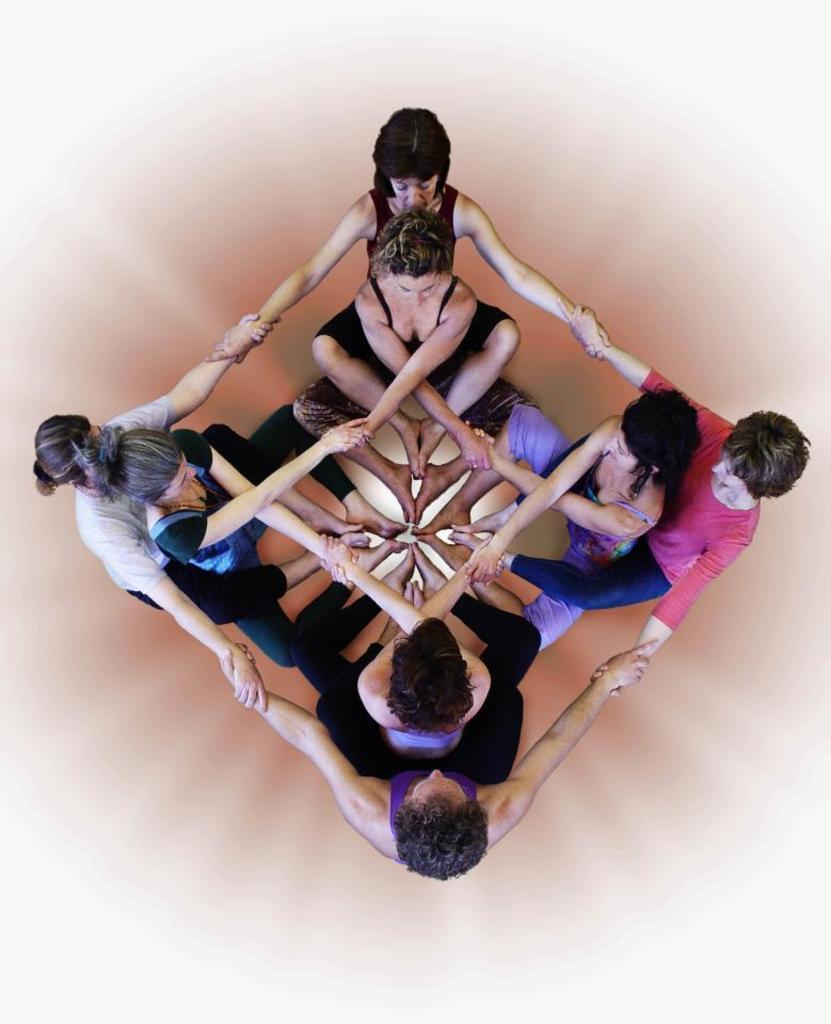Can you describe this image briefly? In this image i can see eight people are holding their hands and legs together and i can see the background is white. 